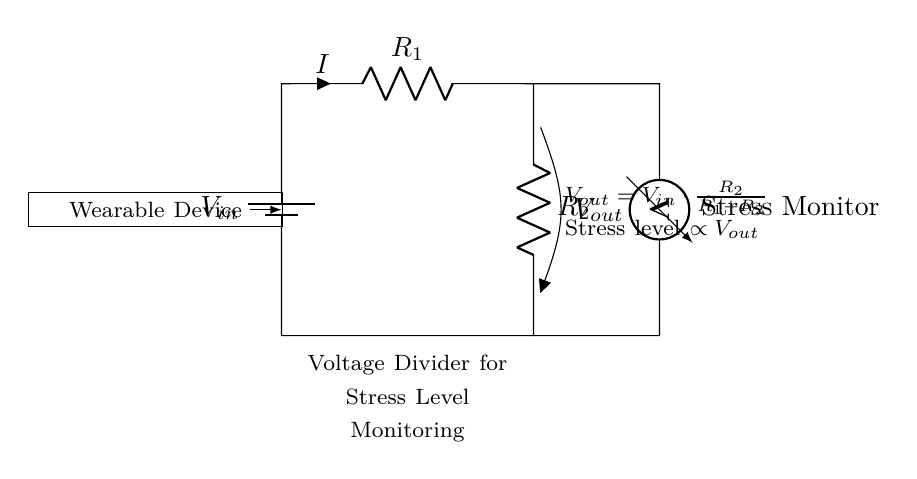What are the resistors in the circuit? The circuit contains two resistors labeled R1 and R2, which form the voltage divider.
Answer: R1, R2 What is the purpose of the voltmeter in this circuit? The voltmeter measures the output voltage, Vout, which correlates to the stress levels in the wearable device.
Answer: Stress Monitor What is the formula for Vout in this voltage divider circuit? The formula is Vout equals Vin multiplied by the ratio of R2 to the sum of R1 and R2, which indicates how the output voltage is determined based on the resistor values.
Answer: Vout = Vin * (R2 / (R1 + R2)) How does increasing R2 affect Vout? Increasing R2 would result in a higher Vout, thus indicating a higher stress level as it increases the ratio in the voltage divider formula.
Answer: Higher Vout What does a higher output voltage signify in this circuit? A higher output voltage corresponds to a higher stress level, which is proportional to the output as per the circuit's design.
Answer: Higher stress level What is the role of the battery in the circuit? The battery provides the input voltage (Vin) necessary for the voltage divider to function, ensuring the circuit operates correctly.
Answer: Power source 